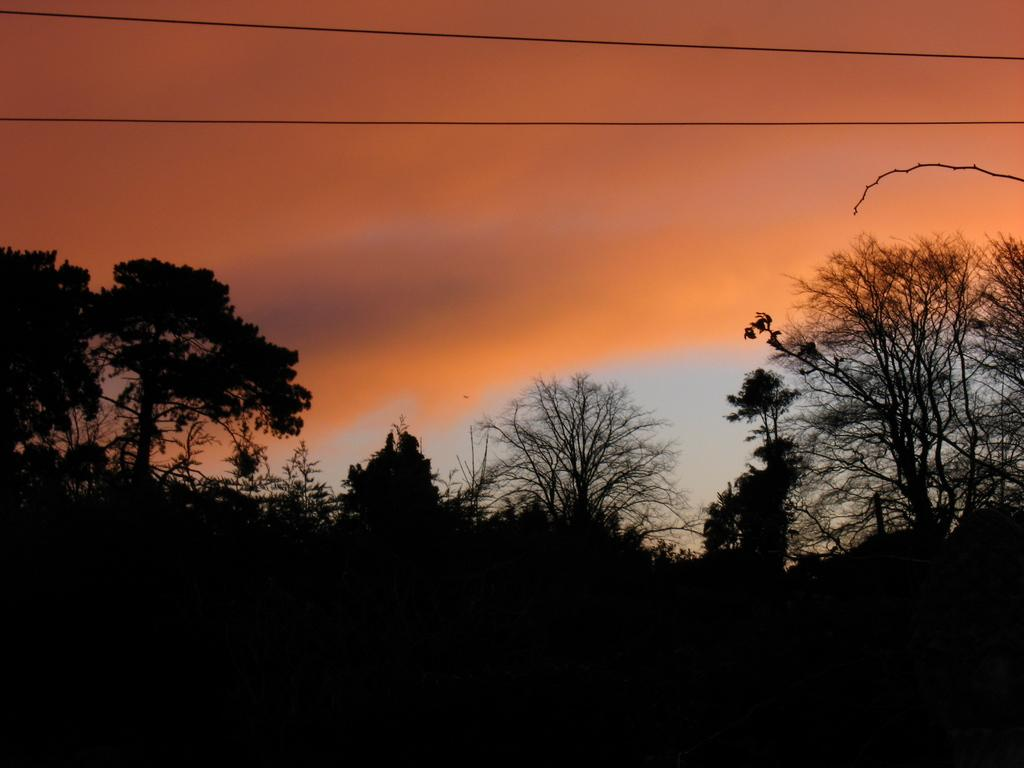What is the primary feature of the image? There are many trees in the image. What can be seen at the top of the image? There are electrical cables at the top of the image. What is visible in the sky in the image? There are clouds in the sky. What type of ice can be seen melting on the airplane in the image? There is no airplane or ice present in the image; it features many trees, electrical cables, and clouds in the sky. 